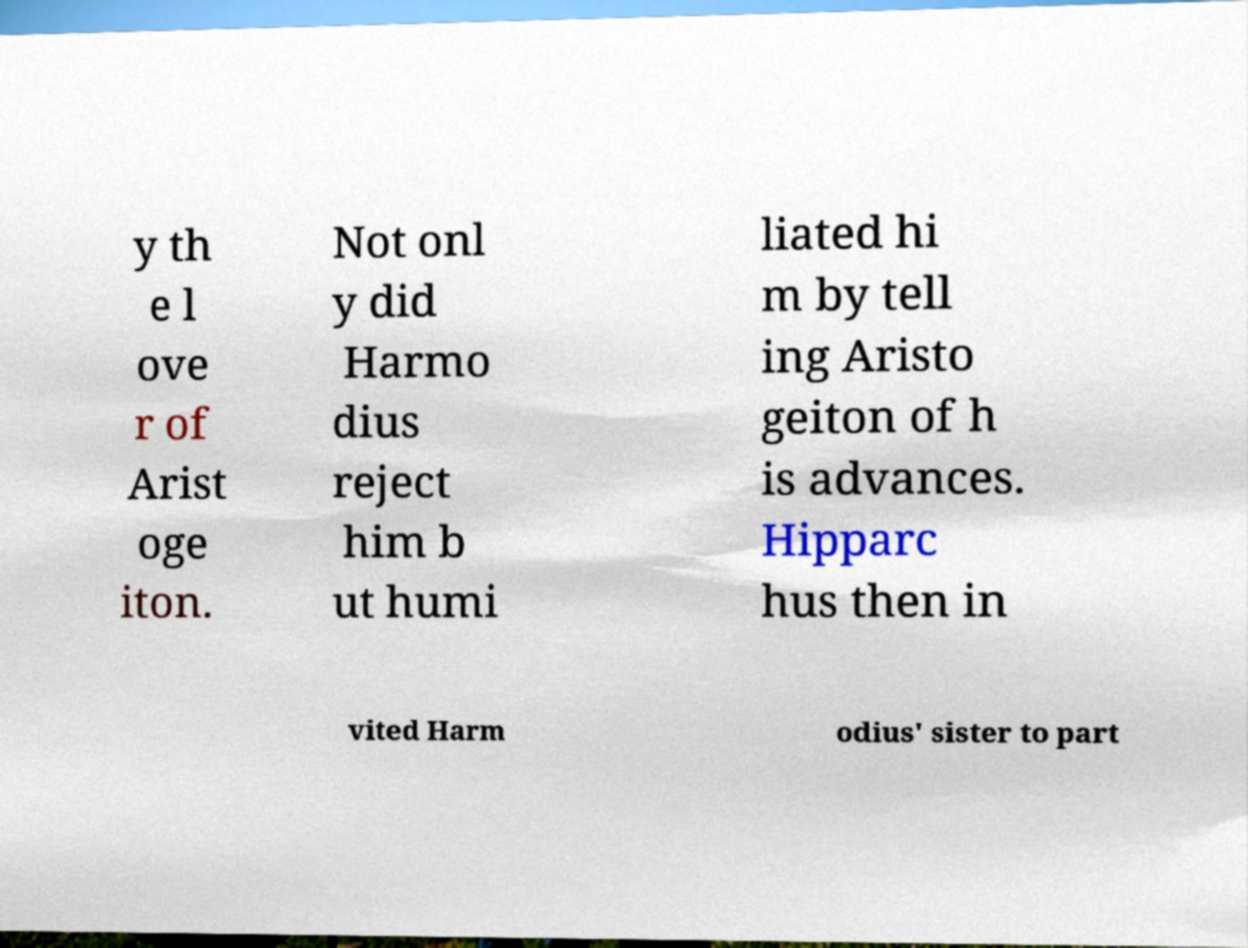There's text embedded in this image that I need extracted. Can you transcribe it verbatim? y th e l ove r of Arist oge iton. Not onl y did Harmo dius reject him b ut humi liated hi m by tell ing Aristo geiton of h is advances. Hipparc hus then in vited Harm odius' sister to part 